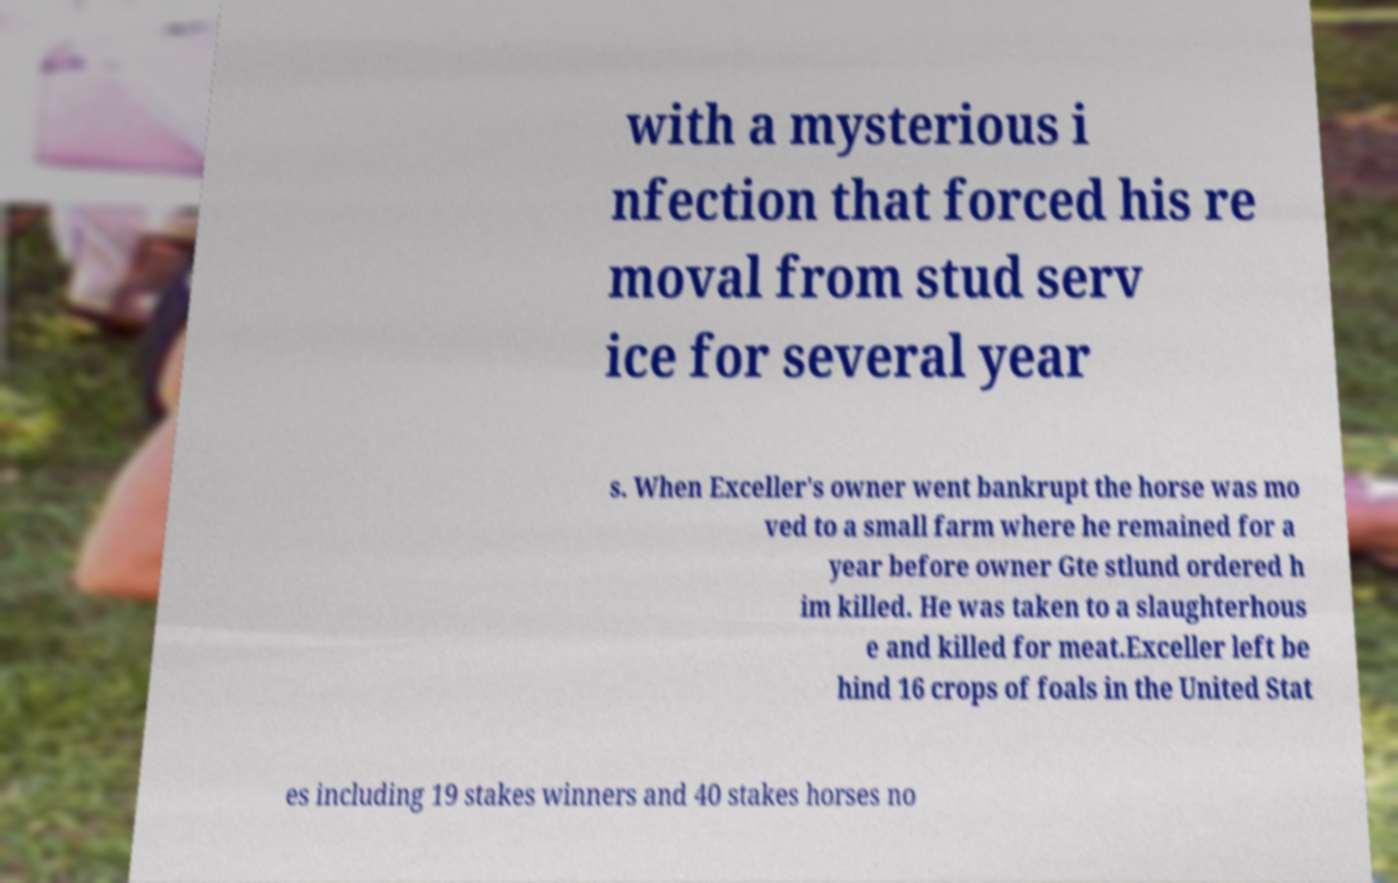For documentation purposes, I need the text within this image transcribed. Could you provide that? with a mysterious i nfection that forced his re moval from stud serv ice for several year s. When Exceller's owner went bankrupt the horse was mo ved to a small farm where he remained for a year before owner Gte stlund ordered h im killed. He was taken to a slaughterhous e and killed for meat.Exceller left be hind 16 crops of foals in the United Stat es including 19 stakes winners and 40 stakes horses no 